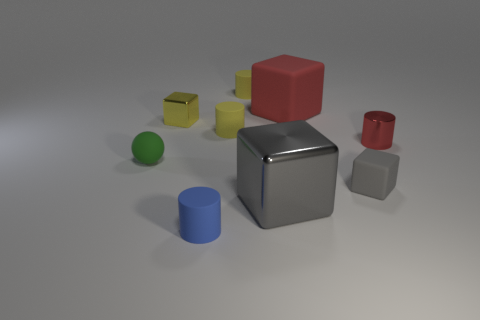Subtract all yellow cylinders. How many were subtracted if there are1yellow cylinders left? 1 Add 1 big metal blocks. How many objects exist? 10 Subtract all cylinders. How many objects are left? 5 Subtract all blue shiny blocks. Subtract all yellow cubes. How many objects are left? 8 Add 8 gray blocks. How many gray blocks are left? 10 Add 8 cyan metal cylinders. How many cyan metal cylinders exist? 8 Subtract 1 yellow blocks. How many objects are left? 8 